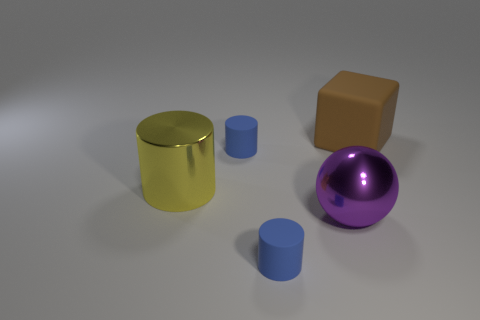Is there anything else that is the same shape as the big brown rubber thing?
Ensure brevity in your answer.  No. What is the color of the big cylinder that is made of the same material as the sphere?
Provide a succinct answer. Yellow. How many other cylinders are the same material as the large yellow cylinder?
Offer a very short reply. 0. How many things are either metal objects or cylinders that are to the right of the yellow cylinder?
Your answer should be very brief. 4. Does the small blue object that is behind the yellow cylinder have the same material as the big purple sphere?
Make the answer very short. No. There is a matte cube that is the same size as the purple sphere; what is its color?
Your answer should be very brief. Brown. Is there another thing that has the same shape as the big yellow thing?
Your answer should be compact. Yes. What is the color of the cylinder that is behind the big object left of the tiny blue matte thing behind the purple object?
Keep it short and to the point. Blue. What number of rubber objects are either small red cylinders or large balls?
Offer a terse response. 0. Is the number of small rubber cylinders that are in front of the large yellow thing greater than the number of yellow cylinders that are to the right of the big purple ball?
Offer a terse response. Yes. 